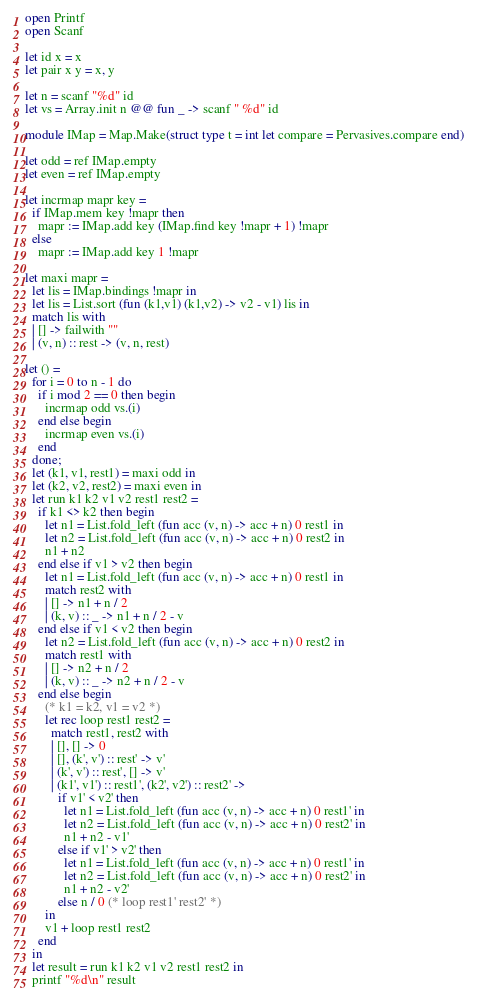<code> <loc_0><loc_0><loc_500><loc_500><_OCaml_>open Printf
open Scanf

let id x = x
let pair x y = x, y

let n = scanf "%d" id
let vs = Array.init n @@ fun _ -> scanf " %d" id

module IMap = Map.Make(struct type t = int let compare = Pervasives.compare end)

let odd = ref IMap.empty
let even = ref IMap.empty

let incrmap mapr key =
  if IMap.mem key !mapr then
    mapr := IMap.add key (IMap.find key !mapr + 1) !mapr
  else
    mapr := IMap.add key 1 !mapr

let maxi mapr =
  let lis = IMap.bindings !mapr in
  let lis = List.sort (fun (k1,v1) (k1,v2) -> v2 - v1) lis in
  match lis with
  | [] -> failwith ""
  | (v, n) :: rest -> (v, n, rest)

let () =
  for i = 0 to n - 1 do
    if i mod 2 == 0 then begin
      incrmap odd vs.(i)
    end else begin
      incrmap even vs.(i)
    end
  done;
  let (k1, v1, rest1) = maxi odd in
  let (k2, v2, rest2) = maxi even in
  let run k1 k2 v1 v2 rest1 rest2 =
    if k1 <> k2 then begin
      let n1 = List.fold_left (fun acc (v, n) -> acc + n) 0 rest1 in
      let n2 = List.fold_left (fun acc (v, n) -> acc + n) 0 rest2 in
      n1 + n2
    end else if v1 > v2 then begin
      let n1 = List.fold_left (fun acc (v, n) -> acc + n) 0 rest1 in
      match rest2 with
      | [] -> n1 + n / 2
      | (k, v) :: _ -> n1 + n / 2 - v
    end else if v1 < v2 then begin
      let n2 = List.fold_left (fun acc (v, n) -> acc + n) 0 rest2 in
      match rest1 with
      | [] -> n2 + n / 2
      | (k, v) :: _ -> n2 + n / 2 - v 
    end else begin
      (* k1 = k2, v1 = v2 *)
      let rec loop rest1 rest2 =
        match rest1, rest2 with
        | [], [] -> 0
        | [], (k', v') :: rest' -> v'
        | (k', v') :: rest', [] -> v'
        | (k1', v1') :: rest1', (k2', v2') :: rest2' ->
          if v1' < v2' then
            let n1 = List.fold_left (fun acc (v, n) -> acc + n) 0 rest1' in
            let n2 = List.fold_left (fun acc (v, n) -> acc + n) 0 rest2' in
            n1 + n2 - v1'
          else if v1' > v2' then
            let n1 = List.fold_left (fun acc (v, n) -> acc + n) 0 rest1' in
            let n2 = List.fold_left (fun acc (v, n) -> acc + n) 0 rest2' in
            n1 + n2 - v2' 
          else n / 0 (* loop rest1' rest2' *)
      in
      v1 + loop rest1 rest2
    end
  in
  let result = run k1 k2 v1 v2 rest1 rest2 in
  printf "%d\n" result
</code> 